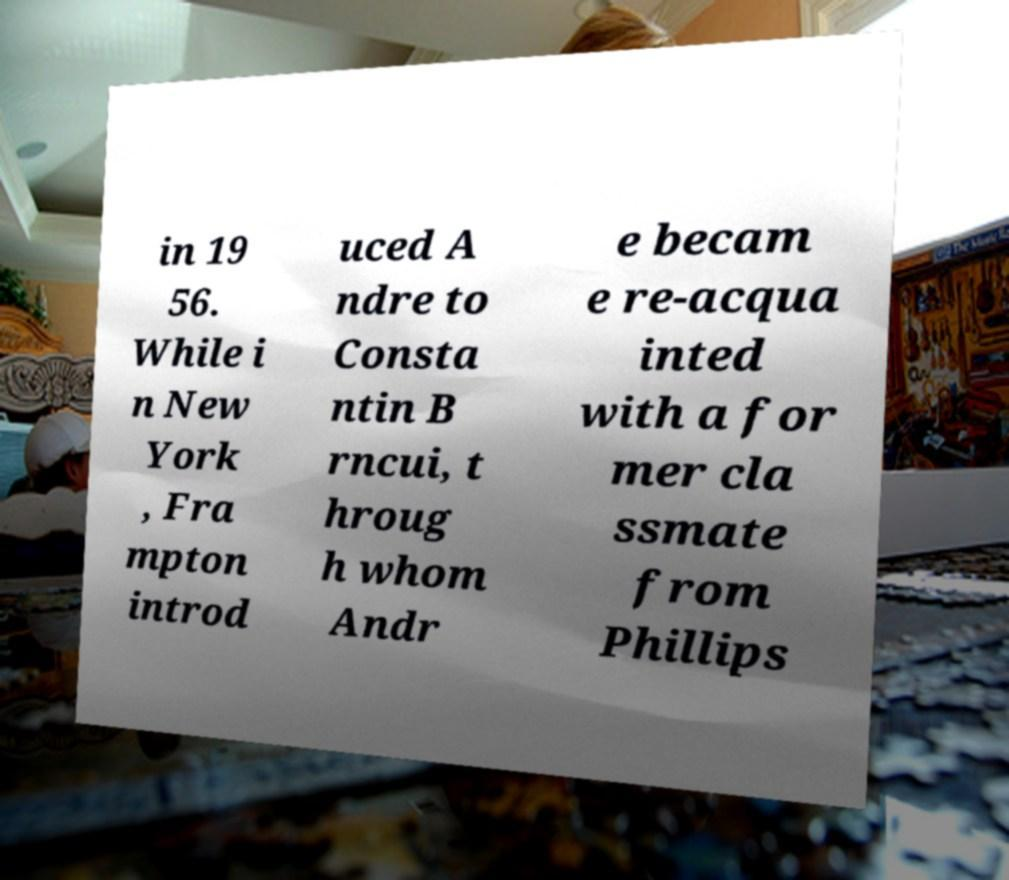There's text embedded in this image that I need extracted. Can you transcribe it verbatim? in 19 56. While i n New York , Fra mpton introd uced A ndre to Consta ntin B rncui, t hroug h whom Andr e becam e re-acqua inted with a for mer cla ssmate from Phillips 